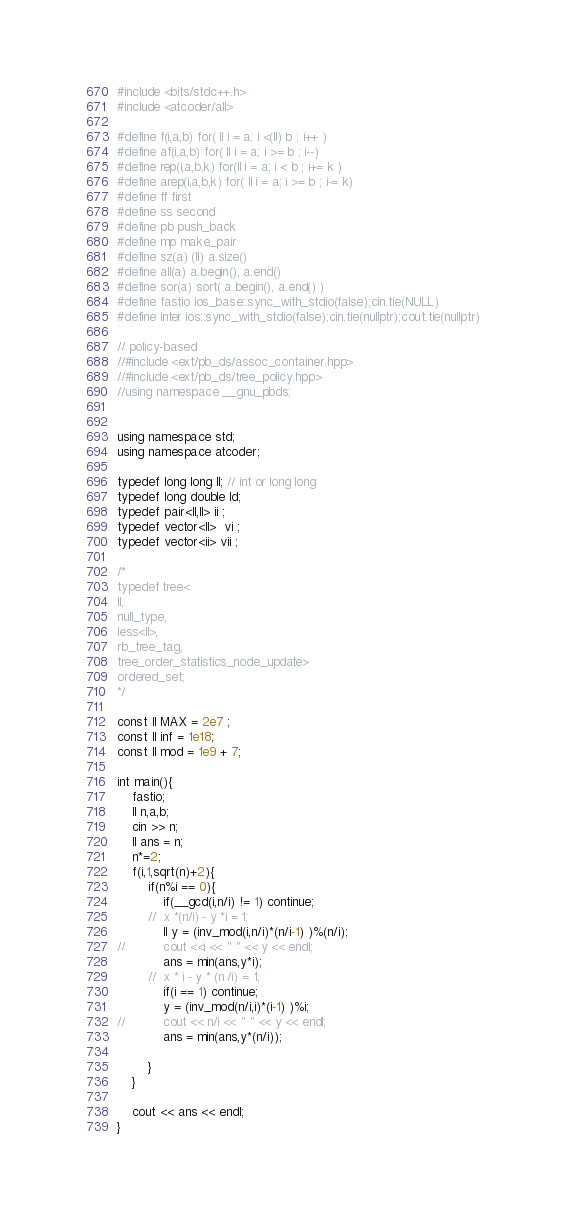<code> <loc_0><loc_0><loc_500><loc_500><_C++_>#include <bits/stdc++.h>
#include <atcoder/all> 

#define f(i,a,b) for( ll i = a; i <(ll) b ; i++ ) 
#define af(i,a,b) for( ll i = a; i >= b ; i--)
#define rep(i,a,b,k) for(ll i = a; i < b ; i+= k )
#define arep(i,a,b,k) for( ll i = a; i >= b ; i-= k)
#define ff first
#define ss second
#define pb push_back
#define mp make_pair
#define sz(a) (ll) a.size()
#define all(a) a.begin(), a.end()
#define sor(a) sort( a.begin(), a.end() )
#define fastio ios_base::sync_with_stdio(false);cin.tie(NULL)
#define inter ios::sync_with_stdio(false);cin.tie(nullptr);cout.tie(nullptr)

// policy-based
//#include <ext/pb_ds/assoc_container.hpp>
//#include <ext/pb_ds/tree_policy.hpp>
//using namespace __gnu_pbds;	


using namespace std;
using namespace atcoder;

typedef long long ll; // int or long long
typedef long double ld;
typedef pair<ll,ll> ii ;
typedef vector<ll>  vi ;
typedef vector<ii> vii ;

/*
typedef tree<
ll,
null_type,
less<ll>,
rb_tree_tag,
tree_order_statistics_node_update>
ordered_set;
*/
 
const ll MAX = 2e7 ;
const ll inf = 1e18;
const ll mod = 1e9 + 7;

int main(){
	fastio;	
	ll n,a,b;
	cin >> n;
	ll ans = n;
	n*=2;
	f(i,1,sqrt(n)+2){
		if(n%i == 0){
			if(__gcd(i,n/i) != 1) continue;
		//	x *(n/i) - y *i = 1;
			ll y = (inv_mod(i,n/i)*(n/i-1) )%(n/i);
//			cout <<i << " " << y << endl;
			ans = min(ans,y*i);
		//	x * i - y * (n /i) = 1;
			if(i == 1) continue;
 			y = (inv_mod(n/i,i)*(i-1) )%i;
//			cout << n/i << " " << y << endl;
			ans = min(ans,y*(n/i));

		}
	}

	cout << ans << endl;
}</code> 